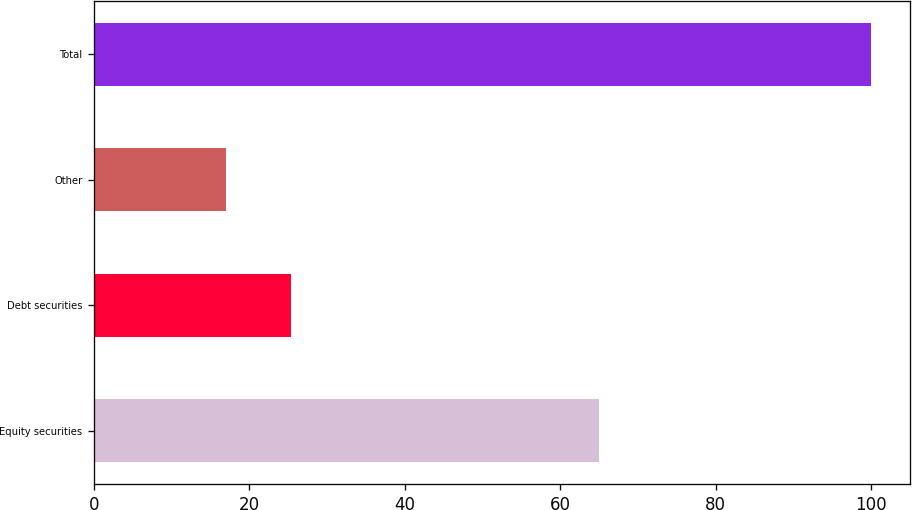Convert chart to OTSL. <chart><loc_0><loc_0><loc_500><loc_500><bar_chart><fcel>Equity securities<fcel>Debt securities<fcel>Other<fcel>Total<nl><fcel>65<fcel>25.3<fcel>17<fcel>100<nl></chart> 